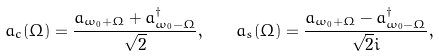Convert formula to latex. <formula><loc_0><loc_0><loc_500><loc_500>a _ { c } ( \Omega ) = \frac { a _ { \omega _ { 0 } + \Omega } + a _ { \omega _ { 0 } - \Omega } ^ { \dag } } { \sqrt { 2 } } , \quad a _ { s } ( \Omega ) = \frac { a _ { \omega _ { 0 } + \Omega } - a _ { \omega _ { 0 } - \Omega } ^ { \dag } } { \sqrt { 2 } i } ,</formula> 